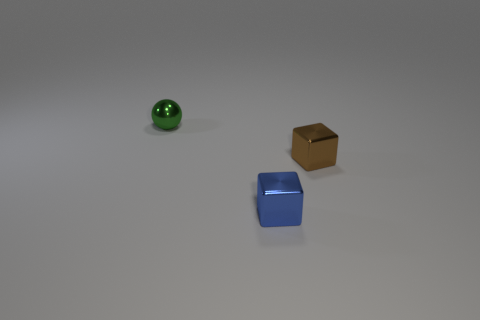Are there any yellow objects of the same size as the blue shiny object?
Your answer should be very brief. No. What number of objects are small brown objects or spheres?
Offer a terse response. 2. There is a block that is behind the tiny blue object; is its size the same as the ball to the left of the small blue metal object?
Provide a short and direct response. Yes. Are there any tiny brown shiny things that have the same shape as the small blue thing?
Give a very brief answer. Yes. Are there fewer small green things behind the blue shiny object than tiny blue metallic things?
Offer a terse response. No. Does the tiny brown thing have the same shape as the tiny green shiny thing?
Ensure brevity in your answer.  No. How big is the object that is to the right of the blue metallic thing?
Provide a short and direct response. Small. There is a green thing that is the same material as the small blue thing; what is its size?
Provide a succinct answer. Small. Is the number of green things less than the number of small gray things?
Provide a succinct answer. No. There is another block that is the same size as the brown shiny block; what is its material?
Your response must be concise. Metal. 